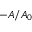Convert formula to latex. <formula><loc_0><loc_0><loc_500><loc_500>- A / A _ { 0 }</formula> 